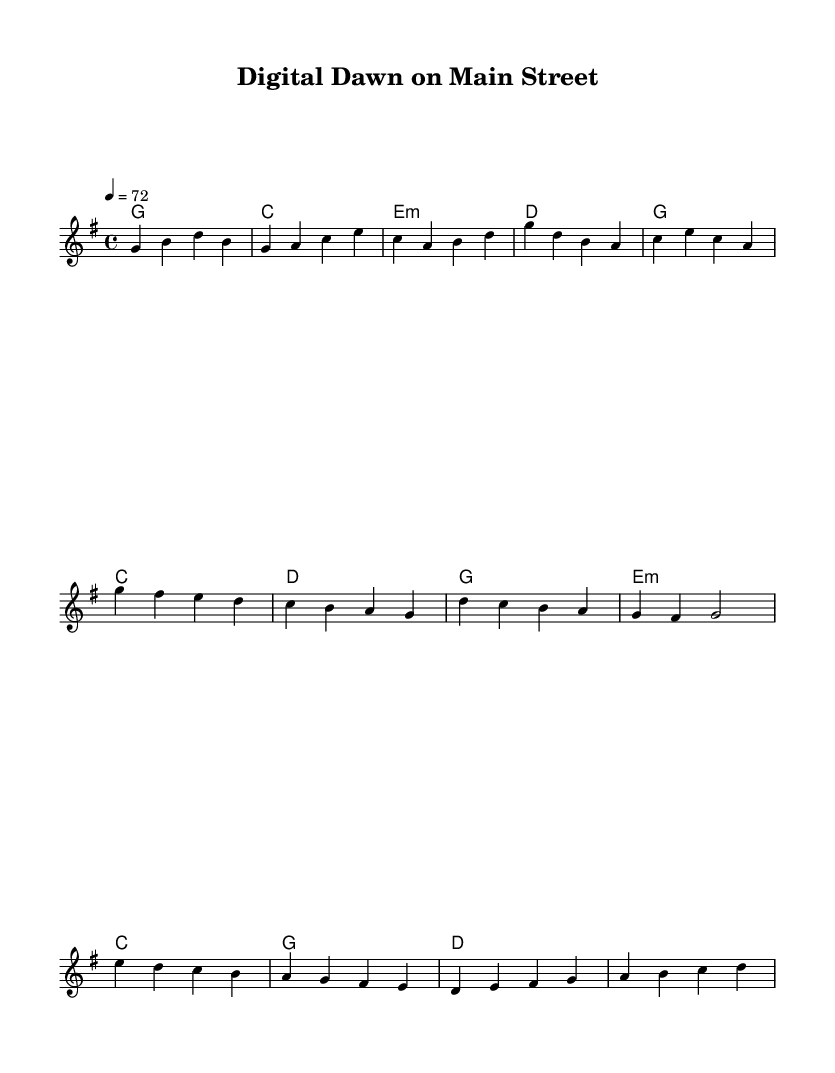what is the key signature of this music? The key signature displayed in the music indicates that it is in G major, which contains one sharp (F#).
Answer: G major what is the time signature of this music? The time signature shown is 4/4, which means there are four beats in each measure and the quarter note gets one beat.
Answer: 4/4 what is the tempo marking for this piece? The tempo marking in the sheet music indicates a speed of 72 beats per minute, set by the notation '4 = 72'.
Answer: 72 how many measures are in the verse section of the music? The verse section contains four measures, each demarcated clearly in the notation.
Answer: 4 what is the chord progression in the chorus? The chord progression consists of four chords: G, C, D, and G, following the pattern indicated in the harmonies.
Answer: G, C, D, G how does the bridge differ from the verse? The bridge introduces a different chord progression and melody, utilizing E minor, C, G, and D chords which contrasts with the verse's G, C, E minor, and D progression.
Answer: Different chord progression what themes does this music reflect in the context of Country Rock? The music reflects themes of nostalgia and change in small-town America, conveying emotions tied to reminiscing about the past and the evolving landscape of rural life.
Answer: Nostalgia and change 